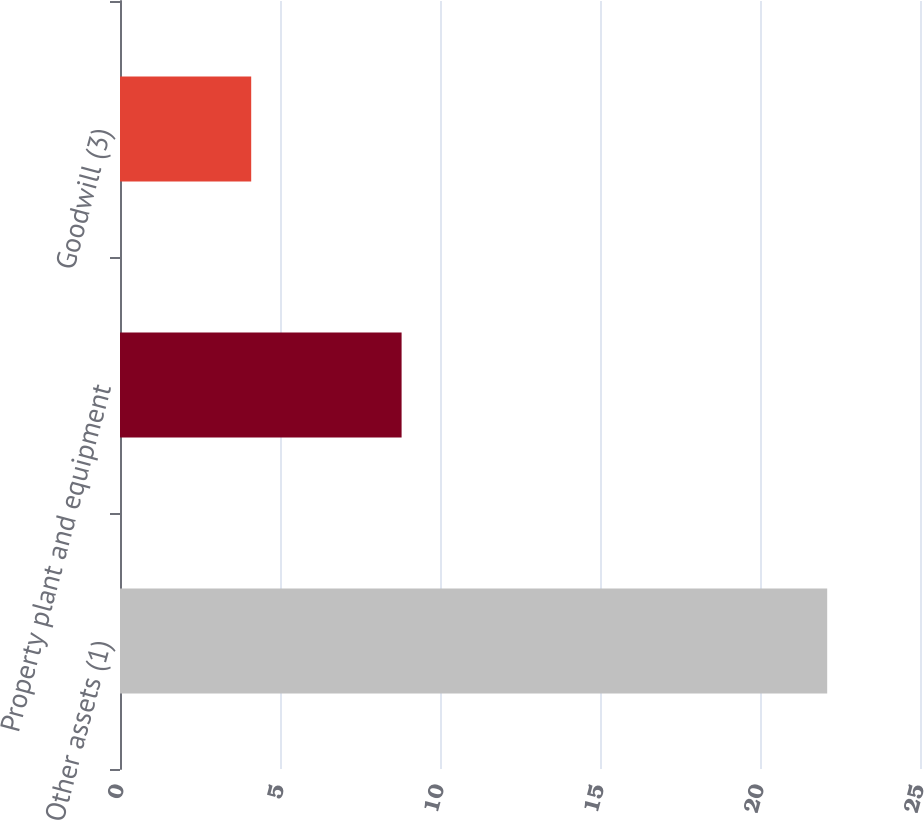Convert chart to OTSL. <chart><loc_0><loc_0><loc_500><loc_500><bar_chart><fcel>Other assets (1)<fcel>Property plant and equipment<fcel>Goodwill (3)<nl><fcel>22.1<fcel>8.8<fcel>4.1<nl></chart> 